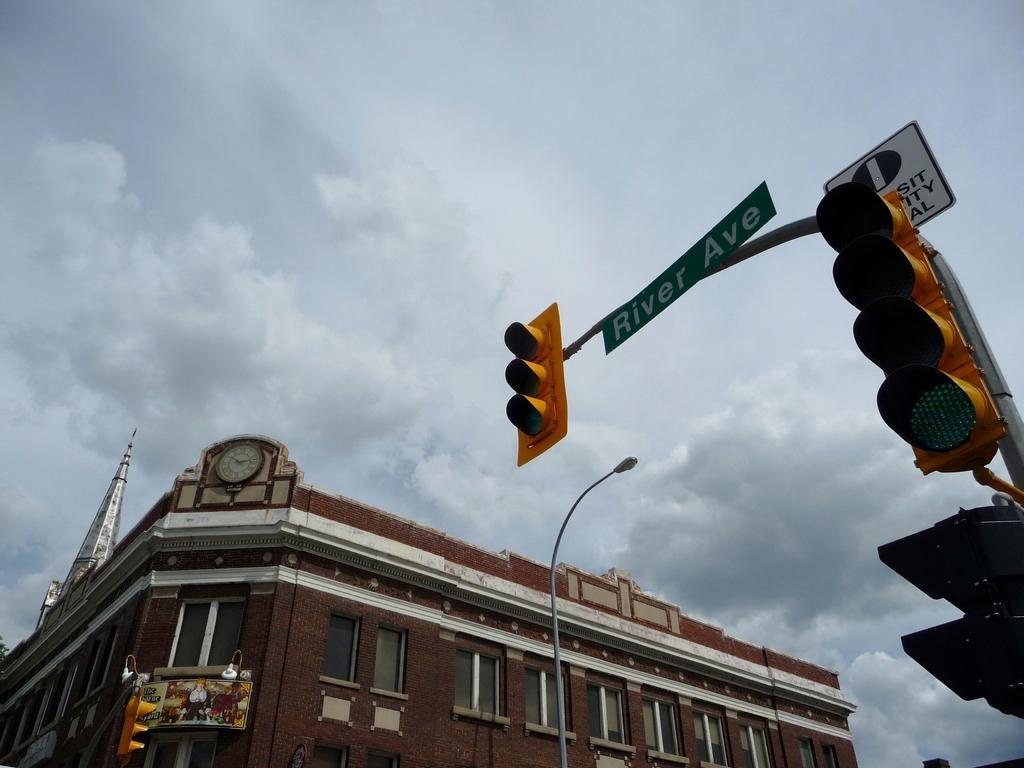Could you give a brief overview of what you see in this image? On the left side, there are signal lights and sign boards, which are attached to the pole. On the right side, there is a light which is attached to the pole, near a building, which is having glass windows. In the background, there are clouds in the sky. 